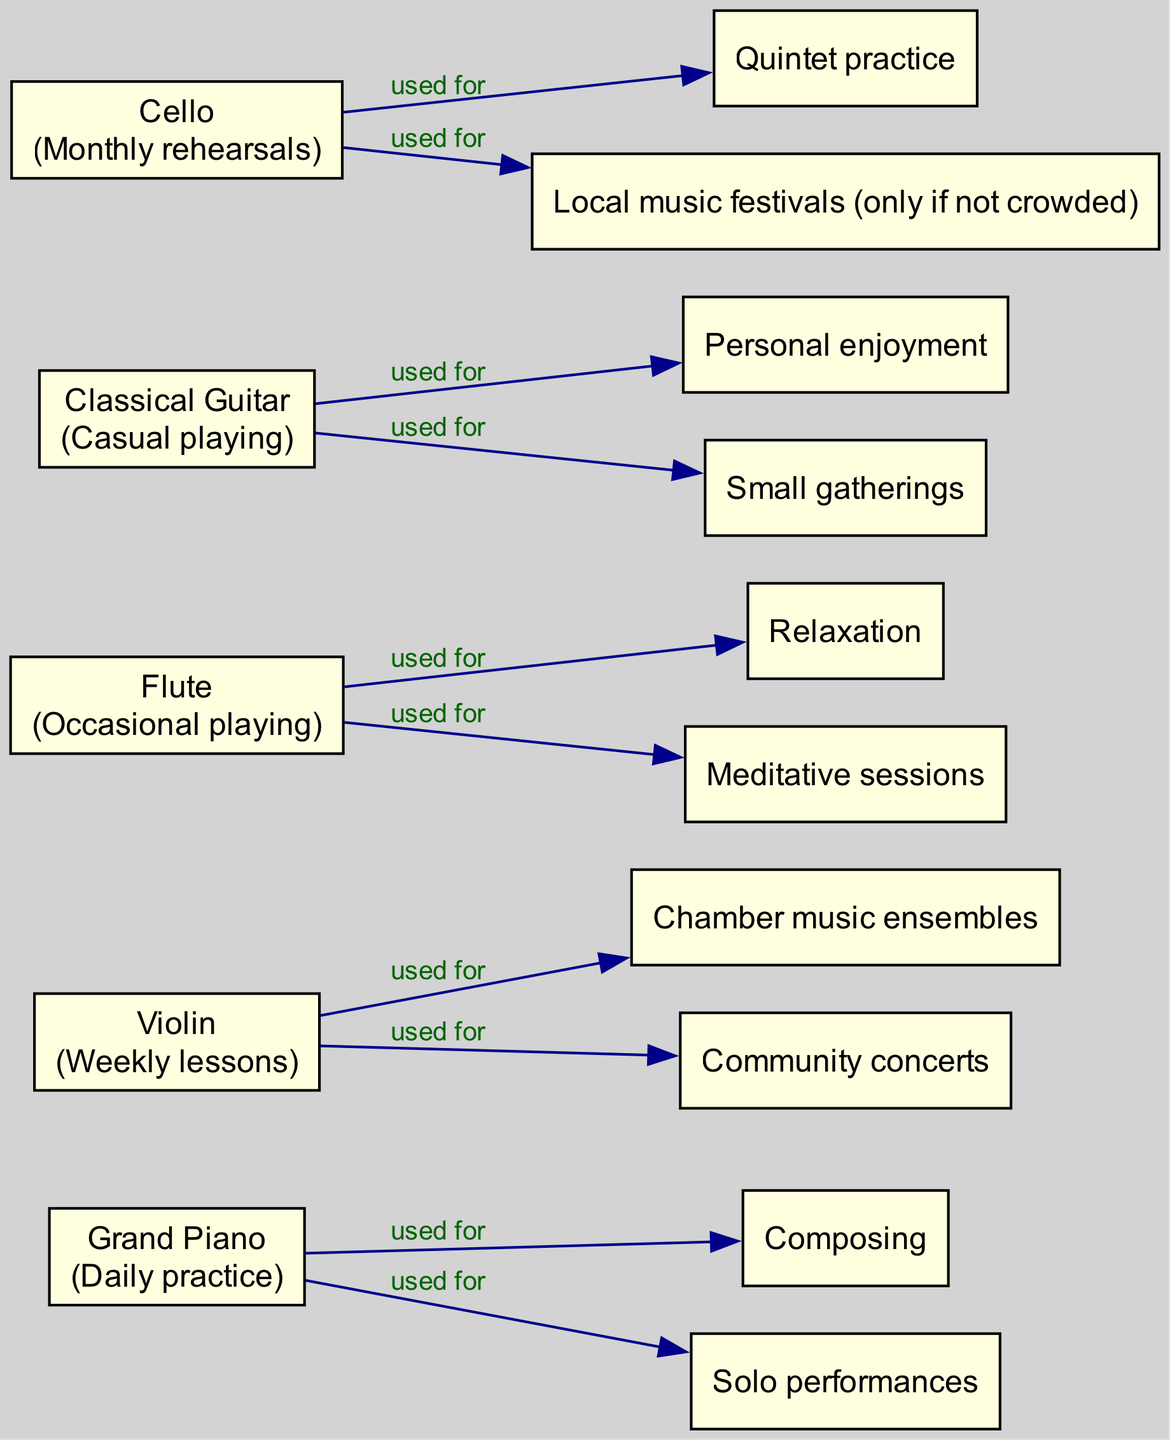What is the usage of the Grand Piano? The diagram shows that the Grand Piano is used for "Daily practice". This information is directly stated within the node representing the Grand Piano.
Answer: Daily practice Which instruments are used for Community concerts? The Violin node indicates that it is used for "Community concerts". After checking all the instruments, the only one with this specific activity is the Violin.
Answer: Violin How many instruments have monthly rehearsals? In the diagram, only the Cello node states that it is used for "Monthly rehearsals". Therefore, there is only one instrument with this frequency of usage.
Answer: 1 What activities are related to the Flute? The diagram shows that the Flute is associated with "Relaxation" and "Meditative sessions". Both of these activities are listed as related activities under the Flute node.
Answer: Relaxation, Meditative sessions Which instrument is used for composing? The Grand Piano node mentions "Composing" as a related activity. By reviewing the nodes, it is established that the Grand Piano is the only instrument used for this purpose.
Answer: Grand Piano How many related activities are associated with the Classical Guitar? The Classical Guitar node displays two related activities: "Personal enjoyment" and "Small gatherings". By counting these, we find that there are two associated activities.
Answer: 2 Which instruments are mentioned in relation to local music festivals? The Cello node indicates that it is used for "Local music festivals (only if not crowded)". After reviewing the other nodes, the Cello is the only instrument linked with this activity.
Answer: Cello Which instrument is the only one listed for daily usage? The Grand Piano node specifies "Daily practice" as its usage. By evaluating each node's usage description, it is clear the Grand Piano is the only one used daily.
Answer: Grand Piano What is the relationship between the Violin and Chamber music ensembles? The diagram indicates that the Violin is used for "Chamber music ensembles" as a related activity. There is a directed edge showing the connection between the Violin and this activity.
Answer: used for 